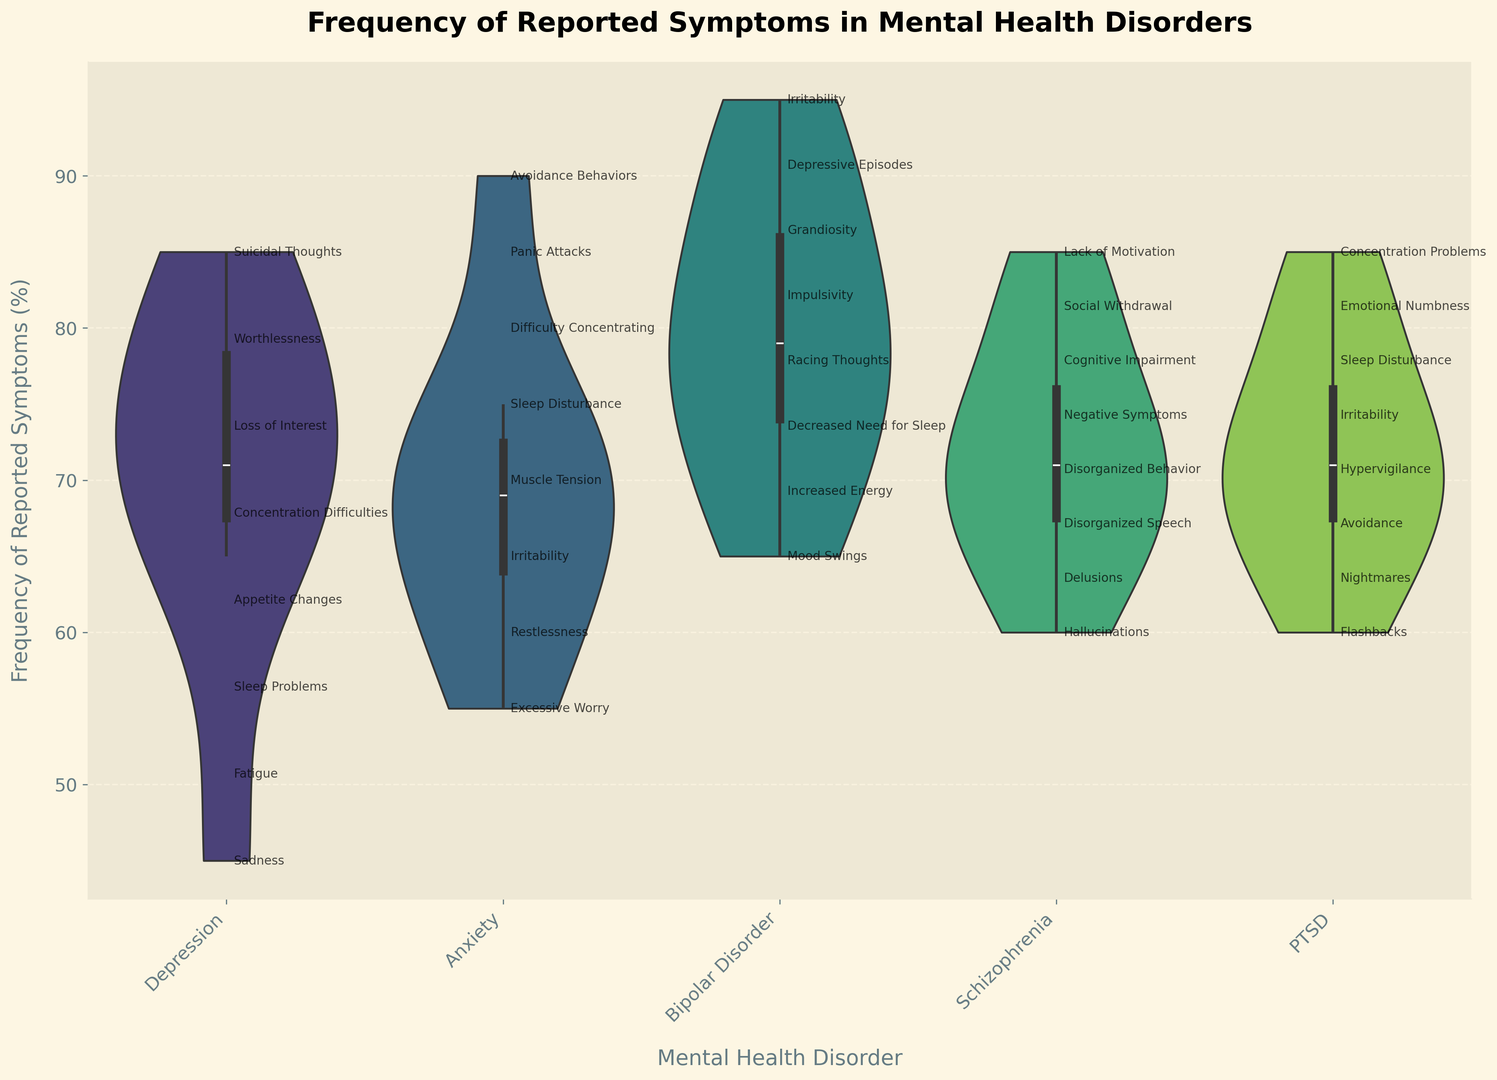Which mental health disorder has the highest median frequency of reported symptoms? The violin plot shows the distribution of frequency for each disorder. The median is indicated by the white dot (or box) inside the violin. By comparing the medians visually, it's evident that PTSD has the highest median frequency.
Answer: PTSD For which disorder do symptoms have the largest range of reported frequencies? The range of reported frequencies can be assessed by the length of the violin plot along the y-axis for each disorder. Bipolar Disorder shows the largest range, spanning from around 65 to 95.
Answer: Bipolar Disorder Between 'Depression' and 'Anxiety', which disorder has a higher maximum frequency of reported symptoms? By looking at the maximum value on the y-axis for both 'Depression' and 'Anxiety', we see that Anxiety peaks higher than Depression. Specifically, Anxiety peaks at 90, while Depression peaks at 85.
Answer: Anxiety Which symptom in Schizophrenia is reported less frequently: 'Negative Symptoms' or 'Social Withdrawal'? By examining the annotated text within the Schizophrenia section of the violin plot, 'Negative Symptoms' shows a frequency of 65%, while 'Social Withdrawal' shows a frequency of 72%.
Answer: Negative Symptoms How does the frequency of 'Hypervigilance' in PTSD compare to 'Excessive Worry' in Anxiety? Comparing the specific annotated points within the PTSD and Anxiety sections, 'Hypervigilance' in PTSD is reported at 85%, while 'Excessive Worry' in Anxiety is reported at 90%. Therefore, 'Excessive Worry' is reported slightly more frequently.
Answer: Excessive Worry Is the frequency of 'Irritability' higher in Bipolar Disorder or PTSD? By examining the specific annotations in their respective sections, Bipolar Disorder lists 'Irritability' at 78%, while PTSD lists 'Irritability' at 65%. Thus, it is higher in Bipolar Disorder.
Answer: Bipolar Disorder What is the visual indication of the frequency distribution in the violin plot? Violin plots use width to indicate the frequency distribution, with wider sections representing more frequent values. Inside the violin, a box or white dot indicates the median value. Additional annotations next to the violin plots label specific symptoms and their frequencies.
Answer: Width and internal markers Which symptom has the lowest frequency in Depression, and how does its frequency compare to the lowest in Bipolar Disorder? In the Depression section, 'Suicidal Thoughts' is annotated with a 45% frequency. In Bipolar Disorder, the lowest frequency is for 'Grandiosity' at 65%. Therefore, 'Suicidal Thoughts' in Depression is lower.
Answer: Suicidal Thoughts (Depression) What is the relative position of 'Sleep Disturbance' in Anxiety compared to its counterpart in PTSD? 'Sleep Disturbance' in Anxiety is annotated at 60%, while in PTSD, it is annotated at 72%. Thus, it has a higher reported frequency in PTSD compared to Anxiety.
Answer: Higher in PTSD Considering all disorders, which has the highest frequency of a single symptom and what is that symptom? By scanning all annotated symptoms across the disorders, Bipolar Disorder's 'Mood Swings' is reported at 95%, which is the highest single symptom frequency among all disorders.
Answer: Mood Swings (Bipolar Disorder) 